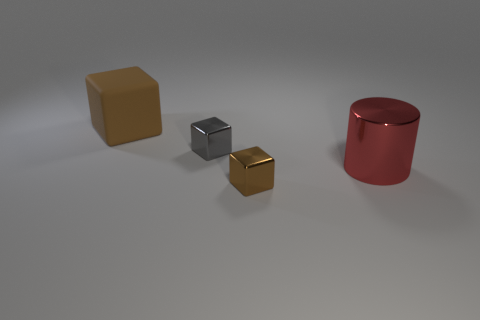How big is the object that is to the left of the big red object and right of the tiny gray thing?
Your answer should be compact. Small. How many objects are either tiny rubber blocks or big matte cubes?
Ensure brevity in your answer.  1. There is a gray shiny block; is its size the same as the brown cube that is behind the small gray metal object?
Your response must be concise. No. There is a metallic cube behind the brown cube that is on the right side of the big brown block on the left side of the large cylinder; what is its size?
Make the answer very short. Small. Is there a brown metallic thing?
Offer a very short reply. Yes. There is another cube that is the same color as the large cube; what is its material?
Give a very brief answer. Metal. How many large cubes have the same color as the cylinder?
Ensure brevity in your answer.  0. How many objects are either large things that are on the right side of the rubber thing or small blocks to the left of the brown metal thing?
Make the answer very short. 2. What number of large cylinders are in front of the metallic thing in front of the cylinder?
Make the answer very short. 0. There is a tiny block that is the same material as the gray thing; what color is it?
Provide a short and direct response. Brown. 